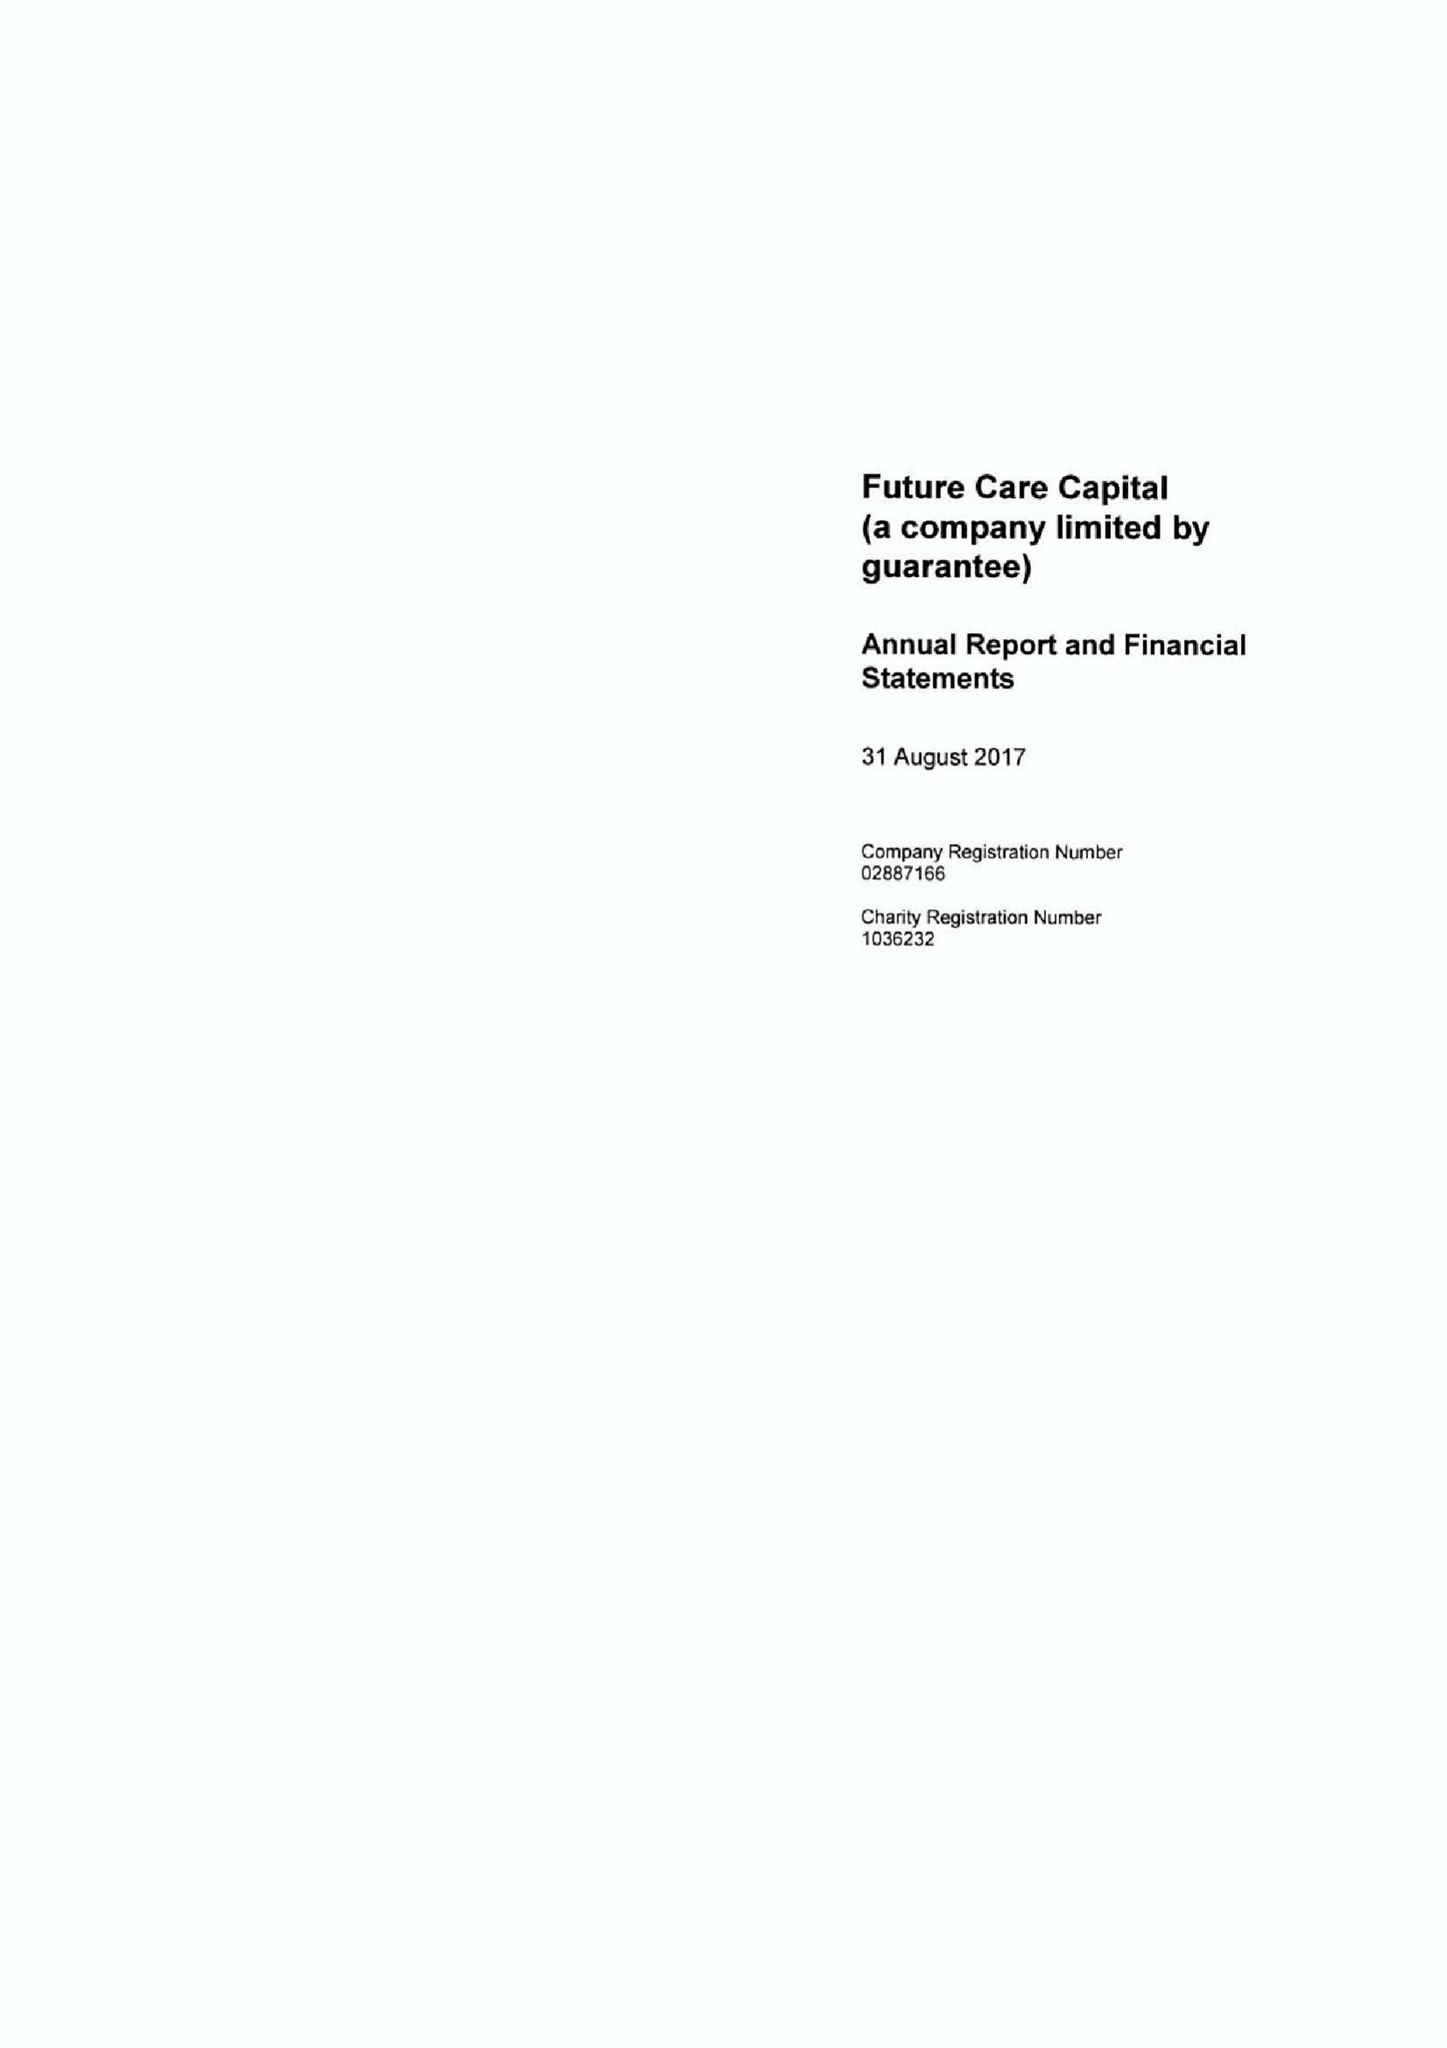What is the value for the charity_number?
Answer the question using a single word or phrase. 1036232 